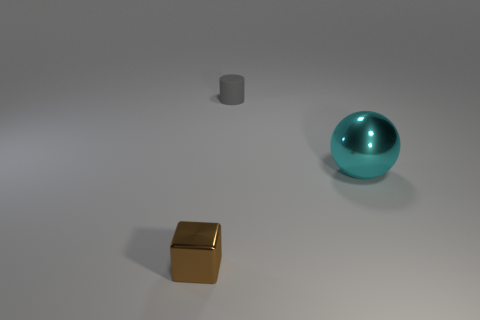Add 1 tiny yellow cubes. How many objects exist? 4 Subtract all balls. How many objects are left? 2 Add 3 big metallic things. How many big metallic things exist? 4 Subtract 0 brown balls. How many objects are left? 3 Subtract all yellow balls. Subtract all yellow blocks. How many balls are left? 1 Subtract all brown rubber cylinders. Subtract all rubber cylinders. How many objects are left? 2 Add 2 tiny brown objects. How many tiny brown objects are left? 3 